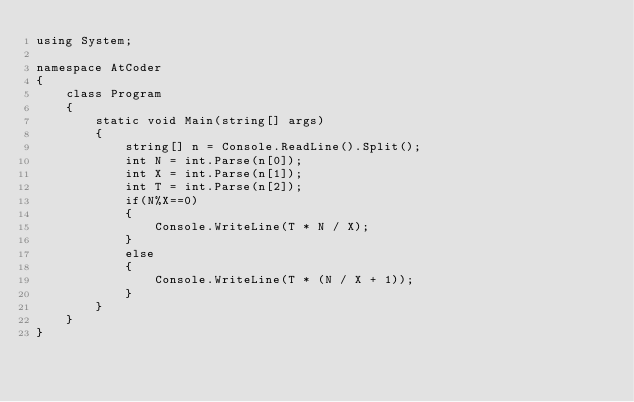<code> <loc_0><loc_0><loc_500><loc_500><_C#_>using System;

namespace AtCoder
{
    class Program
    {
        static void Main(string[] args)
        {
            string[] n = Console.ReadLine().Split();
            int N = int.Parse(n[0]);
            int X = int.Parse(n[1]);
            int T = int.Parse(n[2]);
            if(N%X==0)
            {
                Console.WriteLine(T * N / X);
            }
            else
            {
                Console.WriteLine(T * (N / X + 1));
            }
        }
    }
}</code> 